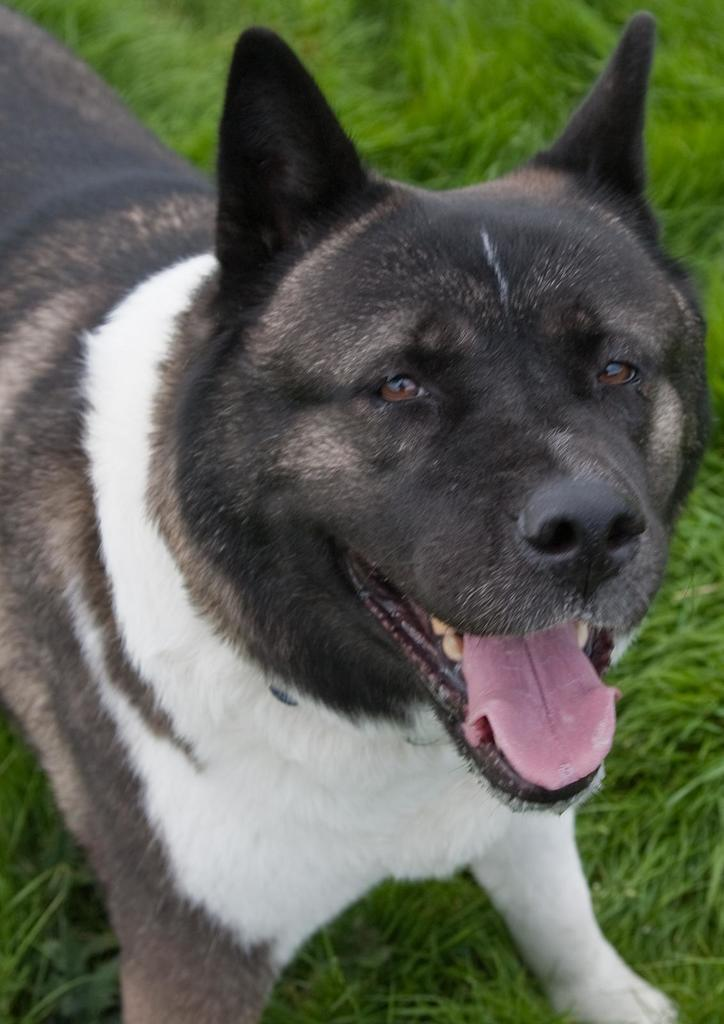What animal can be seen in the image? There is a dog in the image. What is the dog doing in the image? The dog is standing on the ground. What color scheme is used for the dog in the image? The dog is in black and white color. What type of vegetation can be seen in the background of the image? There is grass visible in the background of the image. What type of bat is flying over the dog in the image? There is no bat present in the image; it only features a dog standing on the ground. Can you tell me how many pencils are lying on the grass in the image? There are no pencils present in the image; it only features a dog standing on the ground and grass in the background. 